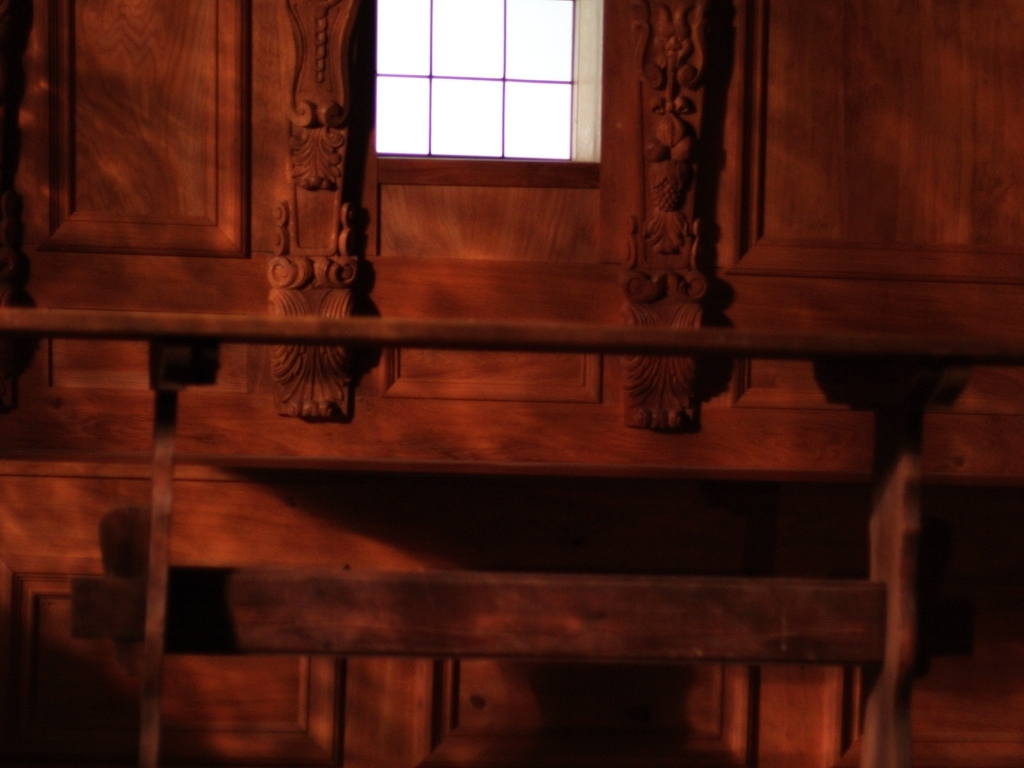Is the exposure of the image sufficient? The image appears slightly underexposed. The shadows are deep, and the highlights in the window lack detail, suggesting that adjusting the exposure could reveal more of the scene's details. 